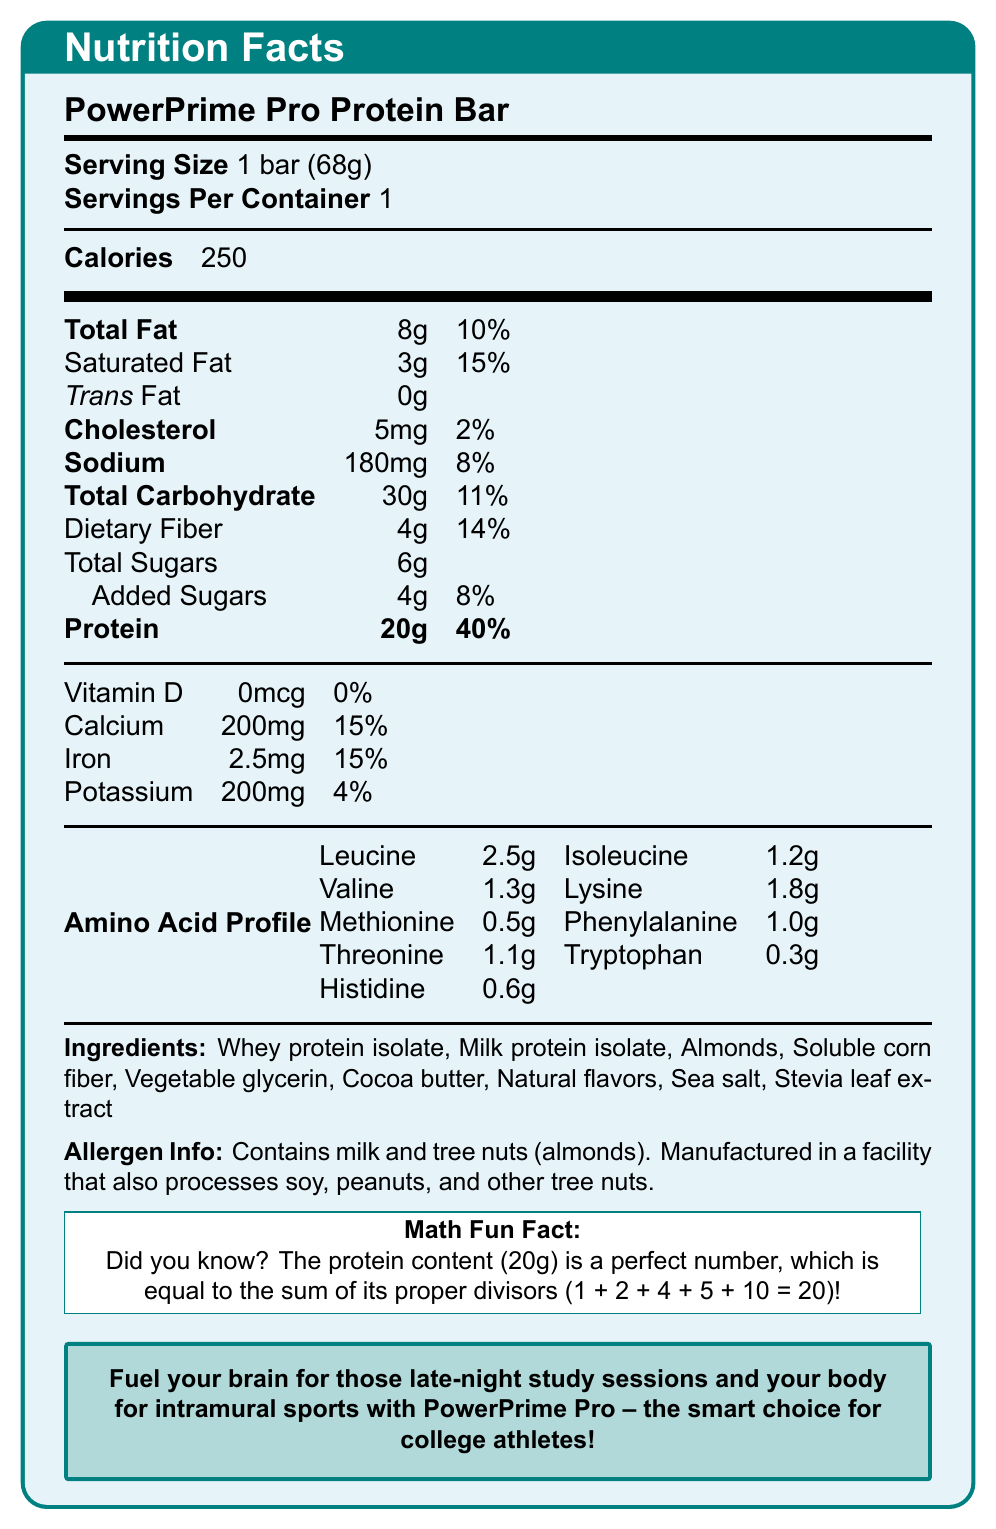what is the serving size? The document lists "Serving Size" as 1 bar (68g).
Answer: 1 bar (68g) how many grams of dietary fiber are in one serving? The document states that "Dietary Fiber" is 4g per serving.
Answer: 4g what percentage of the daily value of protein does one bar provide? The "Protein" section indicates that one bar provides 40% of the daily value.
Answer: 40% how much sodium is in one bar? The document lists "Sodium" as 180mg.
Answer: 180mg name two sources of protein listed in the ingredients. The ingredients section lists "Whey protein isolate" and "Milk protein isolate" as sources of protein.
Answer: Whey protein isolate, Milk protein isolate what is the total fat content of one bar? The document states that the "Total Fat" content is 8g.
Answer: 8g how much potassium is in one bar? The document lists "Potassium" as 200mg.
Answer: 200mg name three amino acids and their amounts found in the bar. The "Amino Acid Profile" lists Leucine at 2.5g, Isoleucine at 1.2g, and Valine at 1.3g.
Answer: Leucine: 2.5g, Isoleucine: 1.2g, Valine: 1.3g how many total grams of sugars are in one bar? The document lists "Total Sugars" as 6g.
Answer: 6g which of the following is an allergen contained in the bar? A. Soy B. Peanuts C. Milk D. Eggs The "Allergen Info" section states that the bar contains milk and tree nuts (almonds).
Answer: C. Milk how many calories are in one serving of the protein bar? A. 100 B. 150 C. 200 D. 250 The document lists "Calories" as 250 per serving.
Answer: D. 250 is there any trans fat in the bar? The document states that there is 0g of trans fat in the bar.
Answer: No summarize the main idea of the document. The Nutritional Facts section details the caloric, fat, carbohydrate, and protein content, along with daily values. It includes an amino acid profile and lists ingredients and allergens, ending with a message targeting college athletes and a fun math fact related to the protein content.
Answer: The document provides the Nutrition Facts for the PowerPrime Pro Protein Bar, highlighting its high protein content suitable for college athletes, along with its vitamin and mineral profile, ingredients, allergen information, and a math fun fact about its protein content. does the protein bar contain any vitamin D? The document states that the Vitamin D content is 0mcg, which is 0% of the daily value.
Answer: No from the document, can you determine the price of the PowerPrime Pro Protein Bar? The document does not provide any information regarding the price of the protein bar.
Answer: Cannot be determined 